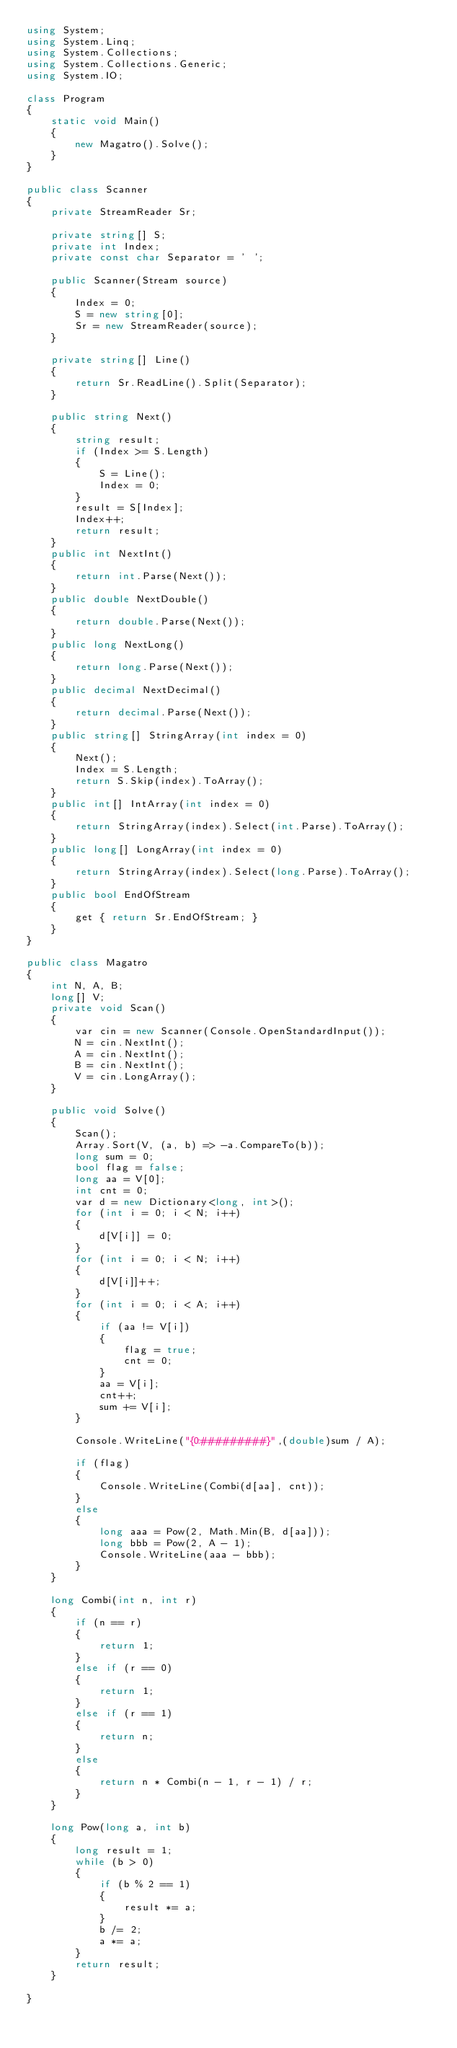Convert code to text. <code><loc_0><loc_0><loc_500><loc_500><_C#_>using System;
using System.Linq;
using System.Collections;
using System.Collections.Generic;
using System.IO;

class Program
{
    static void Main()
    {
        new Magatro().Solve();
    }
}

public class Scanner
{
    private StreamReader Sr;

    private string[] S;
    private int Index;
    private const char Separator = ' ';

    public Scanner(Stream source)
    {
        Index = 0;
        S = new string[0];
        Sr = new StreamReader(source);
    }

    private string[] Line()
    {
        return Sr.ReadLine().Split(Separator);
    }

    public string Next()
    {
        string result;
        if (Index >= S.Length)
        {
            S = Line();
            Index = 0;
        }
        result = S[Index];
        Index++;
        return result;
    }
    public int NextInt()
    {
        return int.Parse(Next());
    }
    public double NextDouble()
    {
        return double.Parse(Next());
    }
    public long NextLong()
    {
        return long.Parse(Next());
    }
    public decimal NextDecimal()
    {
        return decimal.Parse(Next());
    }
    public string[] StringArray(int index = 0)
    {
        Next();
        Index = S.Length;
        return S.Skip(index).ToArray();
    }
    public int[] IntArray(int index = 0)
    {
        return StringArray(index).Select(int.Parse).ToArray();
    }
    public long[] LongArray(int index = 0)
    {
        return StringArray(index).Select(long.Parse).ToArray();
    }
    public bool EndOfStream
    {
        get { return Sr.EndOfStream; }
    }
}

public class Magatro
{
    int N, A, B;
    long[] V;
    private void Scan()
    {
        var cin = new Scanner(Console.OpenStandardInput());
        N = cin.NextInt();
        A = cin.NextInt();
        B = cin.NextInt();
        V = cin.LongArray();
    }

    public void Solve()
    {
        Scan();
        Array.Sort(V, (a, b) => -a.CompareTo(b));
        long sum = 0;
        bool flag = false;
        long aa = V[0];
        int cnt = 0;
        var d = new Dictionary<long, int>();
        for (int i = 0; i < N; i++)
        {
            d[V[i]] = 0;
        }
        for (int i = 0; i < N; i++)
        {
            d[V[i]]++;
        }
        for (int i = 0; i < A; i++)
        {
            if (aa != V[i])
            {
                flag = true;
                cnt = 0;
            }
            aa = V[i];
            cnt++;
            sum += V[i];
        }

        Console.WriteLine("{0:#########}",(double)sum / A);

        if (flag)
        {
            Console.WriteLine(Combi(d[aa], cnt));
        }
        else
        {
            long aaa = Pow(2, Math.Min(B, d[aa]));
            long bbb = Pow(2, A - 1);
            Console.WriteLine(aaa - bbb);
        }
    }

    long Combi(int n, int r)
    {
        if (n == r)
        {
            return 1;
        }
        else if (r == 0)
        {
            return 1;
        }
        else if (r == 1)
        {
            return n;
        }
        else
        {
            return n * Combi(n - 1, r - 1) / r;
        }
    }

    long Pow(long a, int b)
    {
        long result = 1;
        while (b > 0)
        {
            if (b % 2 == 1)
            {
                result *= a;
            }
            b /= 2;
            a *= a;
        }
        return result;
    }

}
</code> 